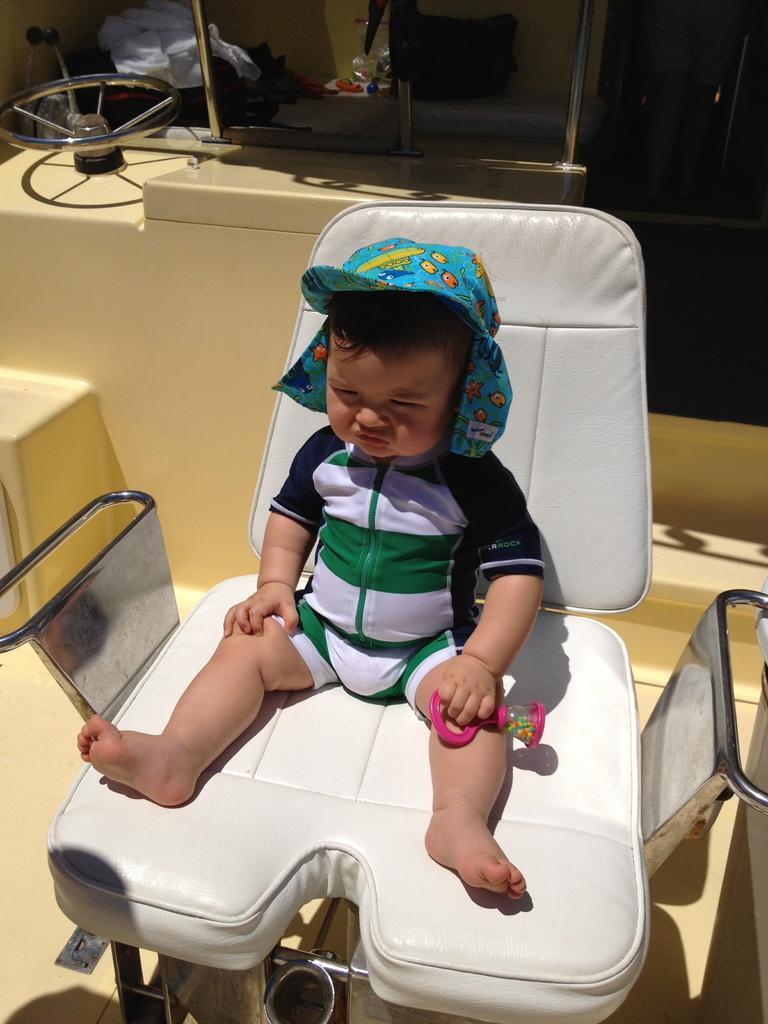Can you describe this image briefly? It looks like a clinic there is a white color chair on which a kid is made to sit , in the background there is some equipment. 